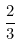Convert formula to latex. <formula><loc_0><loc_0><loc_500><loc_500>\frac { 2 } { 3 }</formula> 